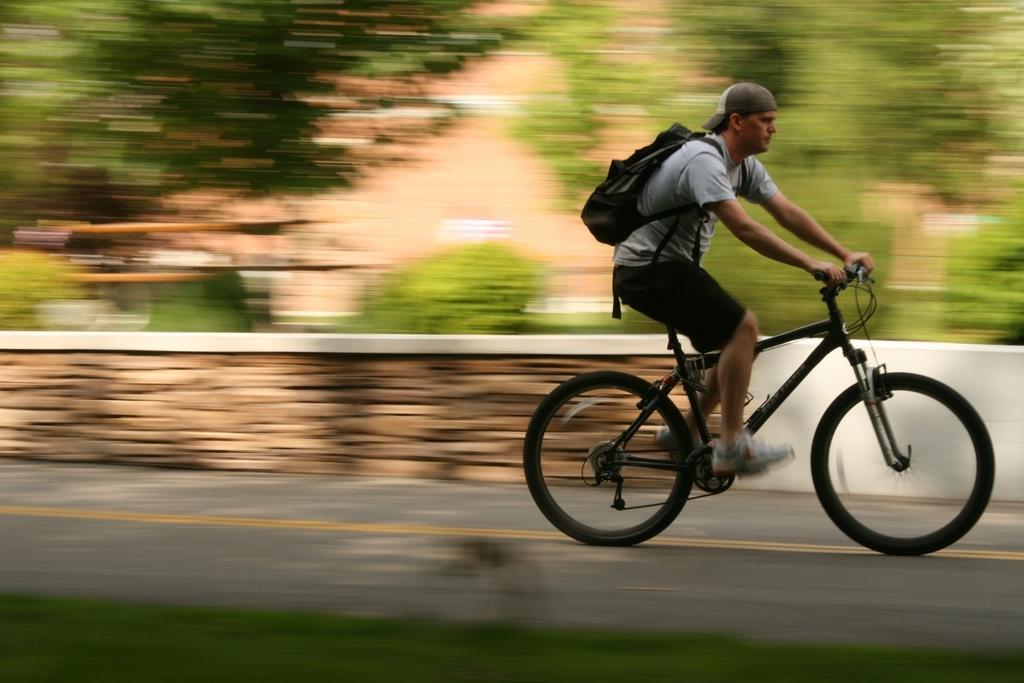Can you describe this image briefly? This image consists of a road, grass patch, a brick wall. At the top of the image there were many trees and plants. In the right side of the image a man is riding a bicycle wearing shoes and backpack along with cap. 